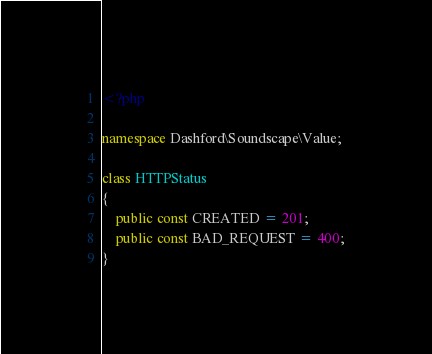<code> <loc_0><loc_0><loc_500><loc_500><_PHP_><?php

namespace Dashford\Soundscape\Value;

class HTTPStatus
{
    public const CREATED = 201;
    public const BAD_REQUEST = 400;
}</code> 